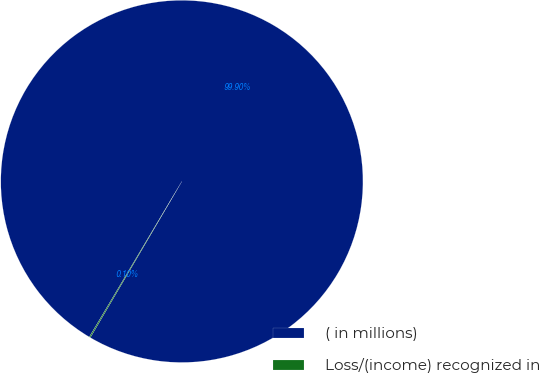Convert chart. <chart><loc_0><loc_0><loc_500><loc_500><pie_chart><fcel>( in millions)<fcel>Loss/(income) recognized in<nl><fcel>99.9%<fcel>0.1%<nl></chart> 